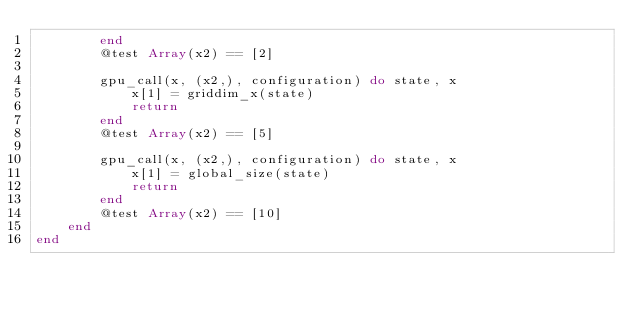Convert code to text. <code><loc_0><loc_0><loc_500><loc_500><_Julia_>        end
        @test Array(x2) == [2]

        gpu_call(x, (x2,), configuration) do state, x
            x[1] = griddim_x(state)
            return
        end
        @test Array(x2) == [5]

        gpu_call(x, (x2,), configuration) do state, x
            x[1] = global_size(state)
            return
        end
        @test Array(x2) == [10]
    end
end
</code> 